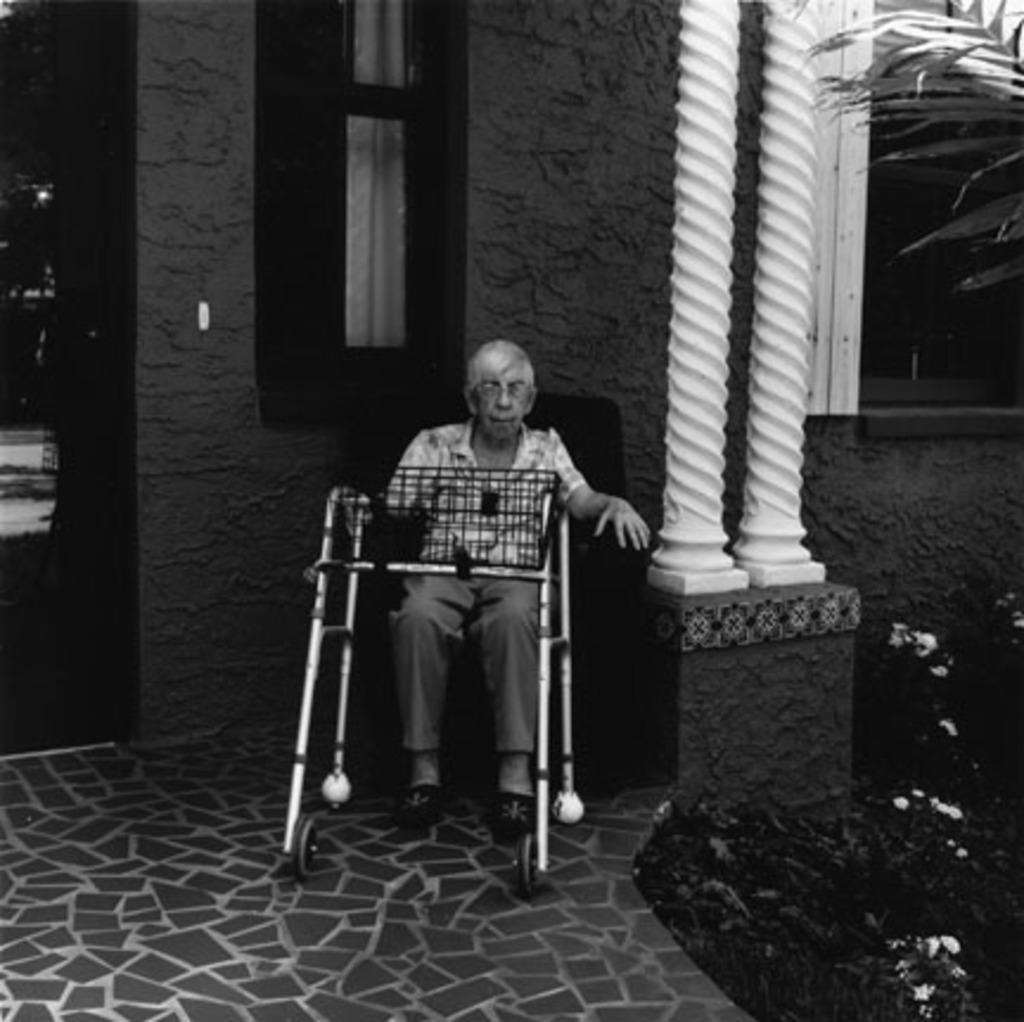How would you summarize this image in a sentence or two? It is a black and white image,there is an old man sitting on a wheelchair and in front of the house there are two white pillars beside the man. 